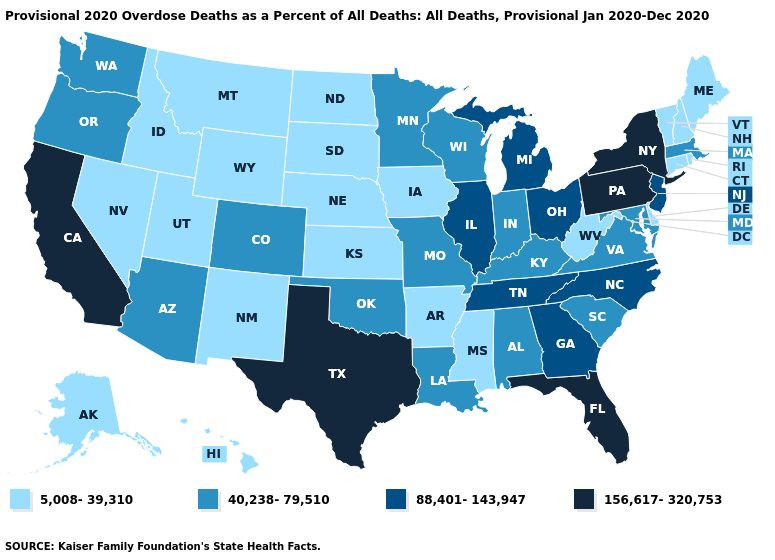What is the lowest value in the USA?
Short answer required. 5,008-39,310. What is the highest value in the Northeast ?
Short answer required. 156,617-320,753. Name the states that have a value in the range 88,401-143,947?
Be succinct. Georgia, Illinois, Michigan, New Jersey, North Carolina, Ohio, Tennessee. What is the lowest value in the Northeast?
Concise answer only. 5,008-39,310. How many symbols are there in the legend?
Write a very short answer. 4. Which states have the lowest value in the USA?
Concise answer only. Alaska, Arkansas, Connecticut, Delaware, Hawaii, Idaho, Iowa, Kansas, Maine, Mississippi, Montana, Nebraska, Nevada, New Hampshire, New Mexico, North Dakota, Rhode Island, South Dakota, Utah, Vermont, West Virginia, Wyoming. Which states have the lowest value in the USA?
Answer briefly. Alaska, Arkansas, Connecticut, Delaware, Hawaii, Idaho, Iowa, Kansas, Maine, Mississippi, Montana, Nebraska, Nevada, New Hampshire, New Mexico, North Dakota, Rhode Island, South Dakota, Utah, Vermont, West Virginia, Wyoming. What is the value of Mississippi?
Concise answer only. 5,008-39,310. What is the value of Wyoming?
Write a very short answer. 5,008-39,310. What is the lowest value in the USA?
Keep it brief. 5,008-39,310. Which states hav the highest value in the West?
Write a very short answer. California. Does the map have missing data?
Keep it brief. No. Among the states that border Texas , which have the highest value?
Quick response, please. Louisiana, Oklahoma. Which states hav the highest value in the South?
Short answer required. Florida, Texas. Which states have the lowest value in the USA?
Be succinct. Alaska, Arkansas, Connecticut, Delaware, Hawaii, Idaho, Iowa, Kansas, Maine, Mississippi, Montana, Nebraska, Nevada, New Hampshire, New Mexico, North Dakota, Rhode Island, South Dakota, Utah, Vermont, West Virginia, Wyoming. 